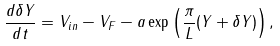Convert formula to latex. <formula><loc_0><loc_0><loc_500><loc_500>\frac { d \delta Y } { d t } = V _ { i n } - V _ { F } - a \exp \left ( \frac { \pi } { L } ( Y + \delta Y ) \right ) ,</formula> 